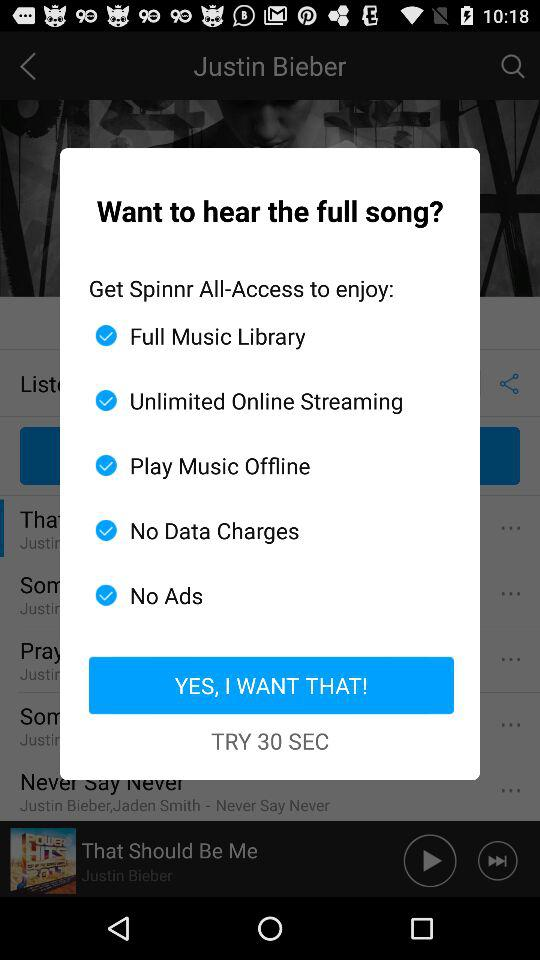Which services can be enjoyed after providing access? The services that can be enjoyed are full music library, unlimited online streaming, play music offline, no data charges and no ads. 